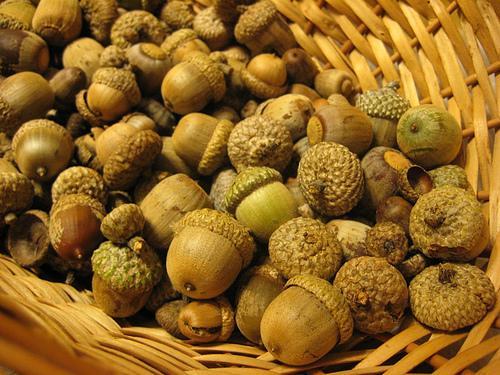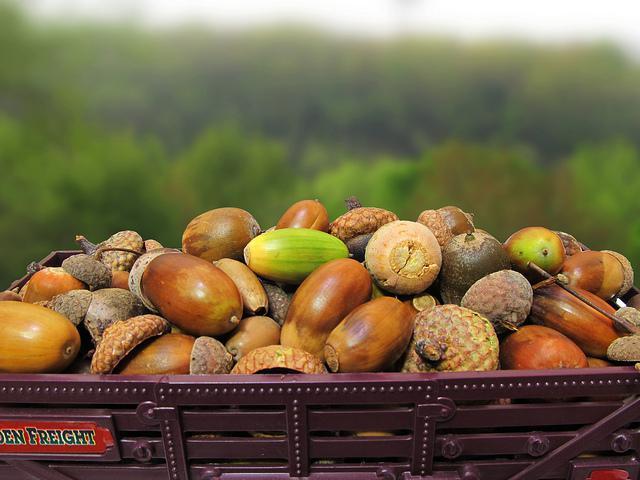The first image is the image on the left, the second image is the image on the right. For the images shown, is this caption "The right image features exactly two green-skinned acorns with their green caps back-to-back." true? Answer yes or no. No. The first image is the image on the left, the second image is the image on the right. Assess this claim about the two images: "There are two green acorns and green acorn tops still attach to each other". Correct or not? Answer yes or no. No. 